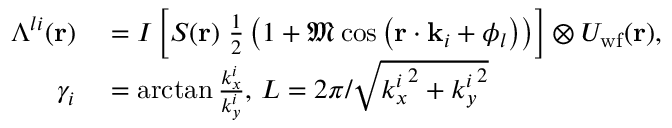<formula> <loc_0><loc_0><loc_500><loc_500>\begin{array} { r l } { \Lambda ^ { l i } ( r ) } & = I \left [ S ( r ) \, \frac { 1 } { 2 } \left ( 1 + \mathfrak { M } \cos \left ( r \cdot k _ { i } + \phi _ { l } \right ) \right ) \right ] \otimes U _ { w f } ( r ) , } \\ { \gamma _ { i } } & = \arctan { \frac { k _ { x } ^ { i } } { k _ { y } ^ { i } } } , \, L = 2 \pi / \sqrt { { k _ { x } ^ { i } } ^ { 2 } + { k _ { y } ^ { i } } ^ { 2 } } } \end{array}</formula> 